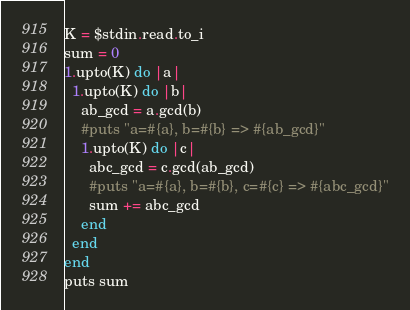<code> <loc_0><loc_0><loc_500><loc_500><_Ruby_>K = $stdin.read.to_i
sum = 0
1.upto(K) do |a|
  1.upto(K) do |b|
    ab_gcd = a.gcd(b)
    #puts "a=#{a}, b=#{b} => #{ab_gcd}"
    1.upto(K) do |c|
      abc_gcd = c.gcd(ab_gcd)
      #puts "a=#{a}, b=#{b}, c=#{c} => #{abc_gcd}"
      sum += abc_gcd
    end
  end
end
puts sum
</code> 